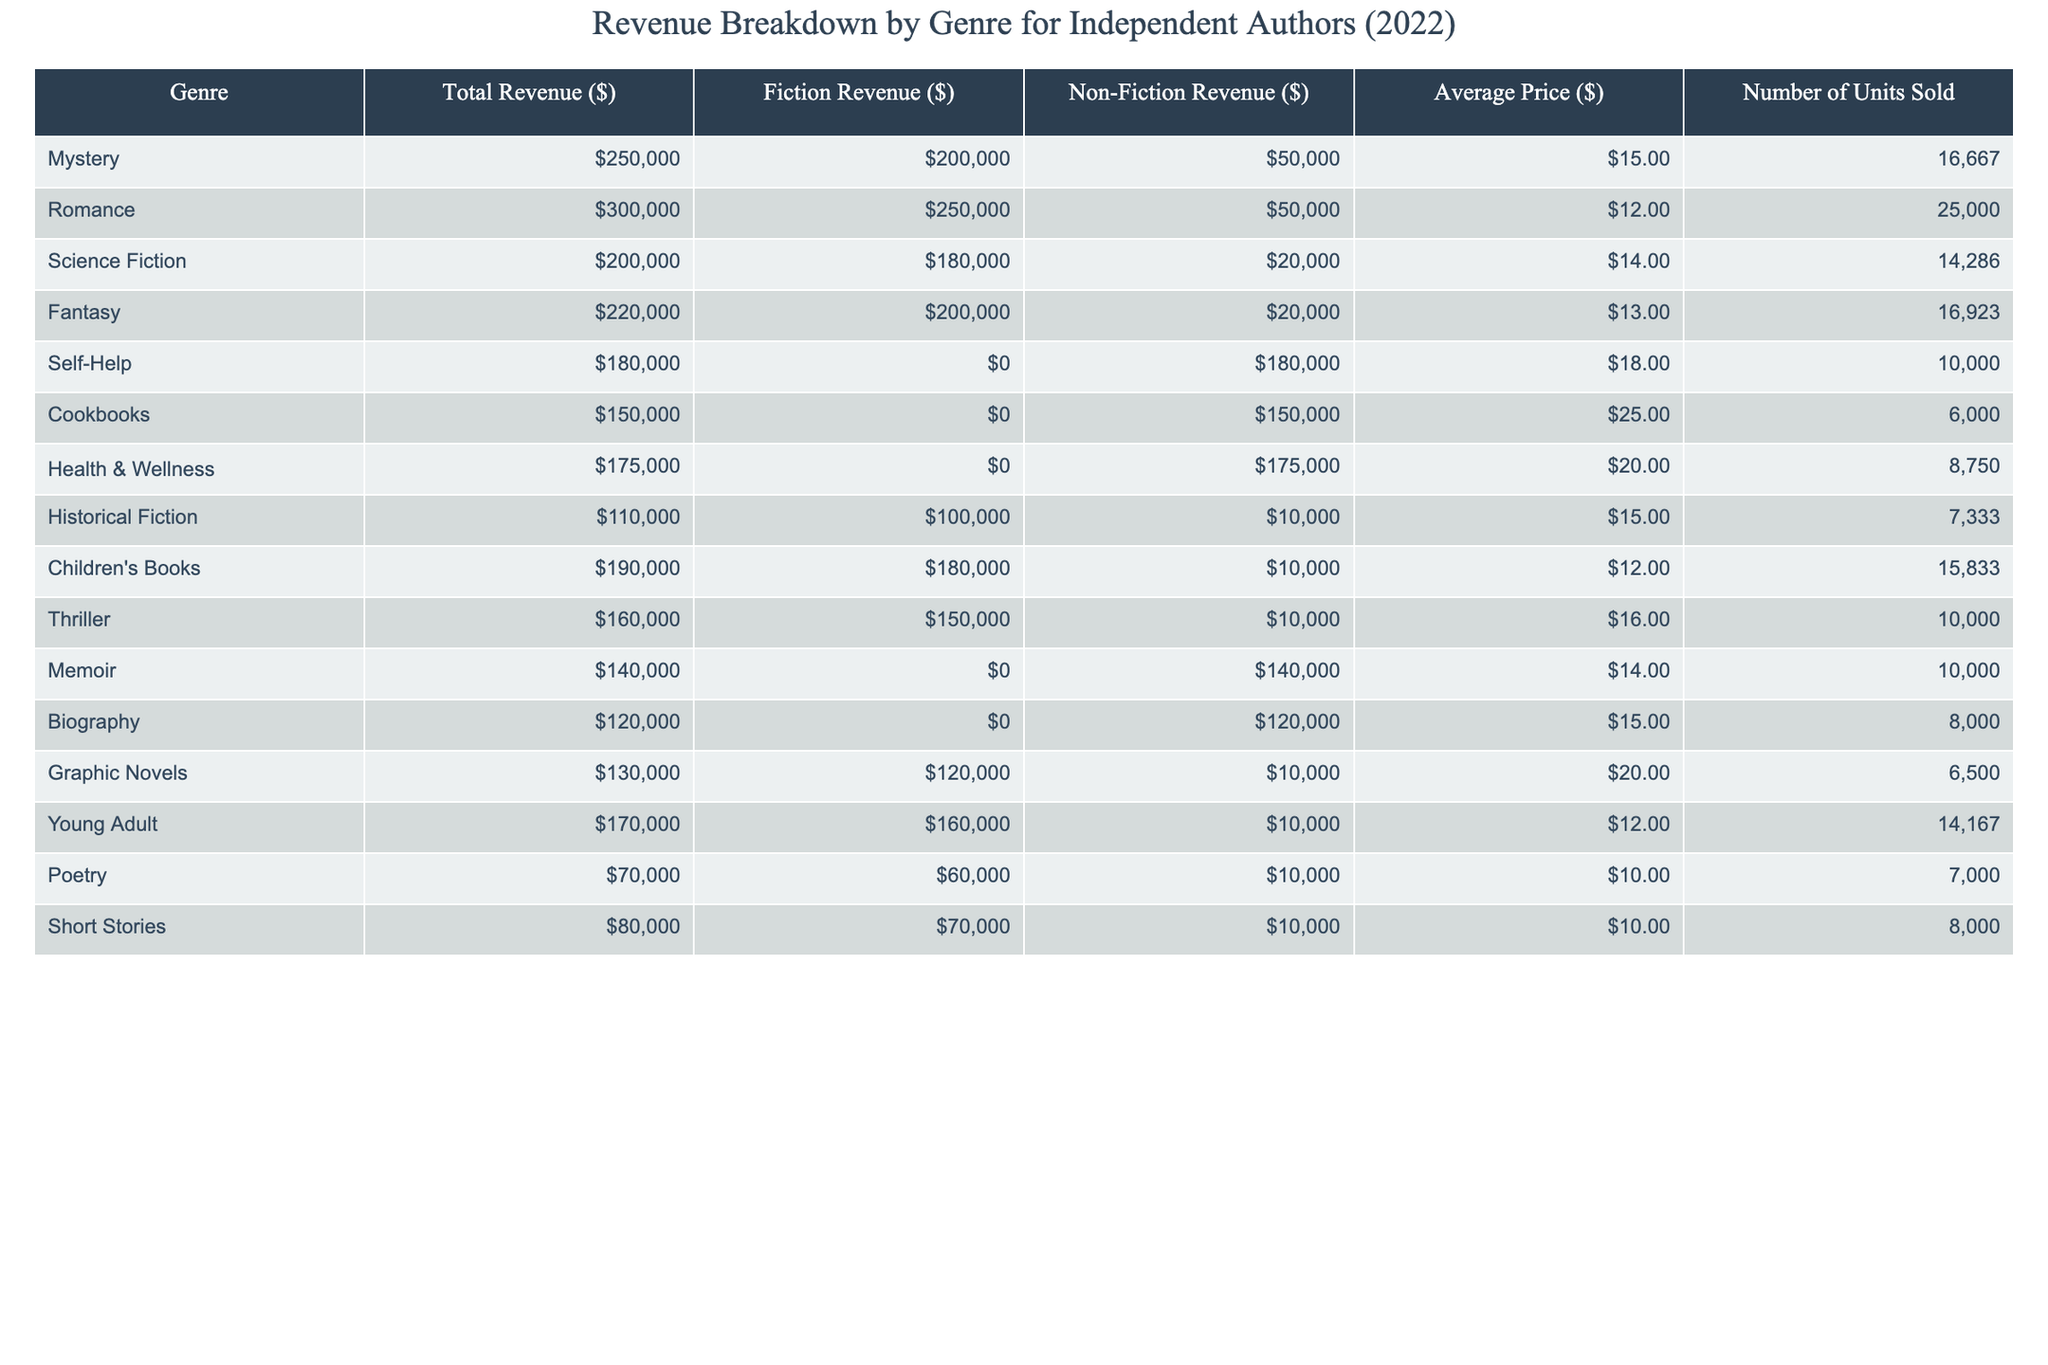What is the total revenue for the Romance genre? By referring to the table, the Total Revenue for the Romance genre is expressed as $300,000.
Answer: $300,000 Which genre had the highest non-fiction revenue? The table shows that the Self-Help genre generated $180,000 in non-fiction revenue, which is higher than any other genre listed.
Answer: Self-Help How much revenue did the Mystery genre generate from fiction sales? The table indicates that the Mystery genre has a Fiction Revenue of $200,000.
Answer: $200,000 What is the average price of cookbooks? According to the table, the Average Price for Cookbooks is given as $25.00.
Answer: $25.00 Which genre sold the most units, and how many were sold? Looking at the table, the Romance genre sold the most units at 25,000.
Answer: Romance, 25,000 units What is the total revenue from non-fiction for the Health & Wellness genre and the Memoir genre combined? The Health & Wellness genre has non-fiction revenue of $175,000, and the Memoir genre has $140,000, so their total is $175,000 + $140,000 = $315,000.
Answer: $315,000 Is the total revenue for Fantasy genre greater than $200,000? The Fantasy genre has a Total Revenue of $220,000, which is indeed greater than $200,000. Thus, the statement is true.
Answer: Yes How does the average price of Children's Books compare to the average price of Poetry? The Average Price for Children's Books is $12.00, while for Poetry it is $10.00. Therefore, Children's Books are more expensive.
Answer: Children's Books are more expensive If we consider only fiction, what is the total revenue generated from the top three genres? The top three genres by fiction revenue are Romance ($250,000), Mystery ($200,000), and Fantasy ($200,000). Adding these yields $250,000 + $200,000 + $200,000 = $650,000.
Answer: $650,000 What percentage of total revenue does the Biography genre contribute? The Total Revenue across all genres is $2,430,000. The Biography genre contributes $120,000, so the percentage is ($120,000 / $2,430,000) * 100 ≈ 4.94%.
Answer: Approximately 4.94% 